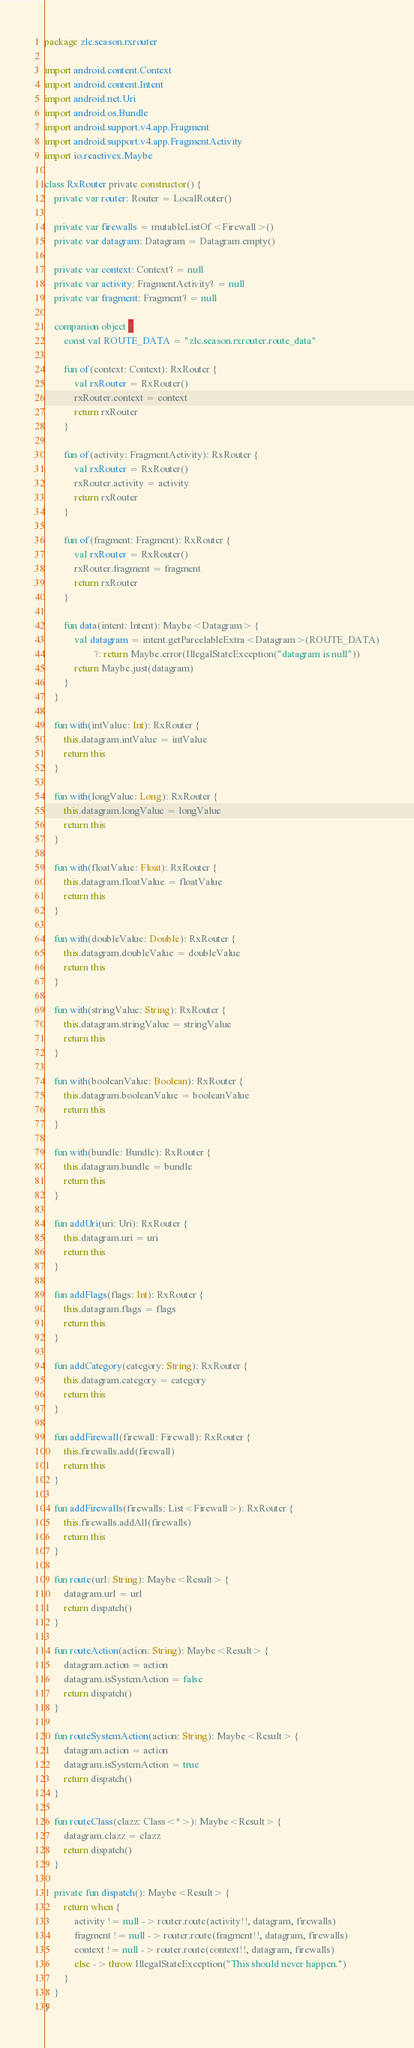<code> <loc_0><loc_0><loc_500><loc_500><_Kotlin_>package zlc.season.rxrouter

import android.content.Context
import android.content.Intent
import android.net.Uri
import android.os.Bundle
import android.support.v4.app.Fragment
import android.support.v4.app.FragmentActivity
import io.reactivex.Maybe

class RxRouter private constructor() {
    private var router: Router = LocalRouter()

    private var firewalls = mutableListOf<Firewall>()
    private var datagram: Datagram = Datagram.empty()

    private var context: Context? = null
    private var activity: FragmentActivity? = null
    private var fragment: Fragment? = null

    companion object {
        const val ROUTE_DATA = "zlc.season.rxrouter.route_data"

        fun of(context: Context): RxRouter {
            val rxRouter = RxRouter()
            rxRouter.context = context
            return rxRouter
        }

        fun of(activity: FragmentActivity): RxRouter {
            val rxRouter = RxRouter()
            rxRouter.activity = activity
            return rxRouter
        }

        fun of(fragment: Fragment): RxRouter {
            val rxRouter = RxRouter()
            rxRouter.fragment = fragment
            return rxRouter
        }

        fun data(intent: Intent): Maybe<Datagram> {
            val datagram = intent.getParcelableExtra<Datagram>(ROUTE_DATA)
                    ?: return Maybe.error(IllegalStateException("datagram is null"))
            return Maybe.just(datagram)
        }
    }

    fun with(intValue: Int): RxRouter {
        this.datagram.intValue = intValue
        return this
    }

    fun with(longValue: Long): RxRouter {
        this.datagram.longValue = longValue
        return this
    }

    fun with(floatValue: Float): RxRouter {
        this.datagram.floatValue = floatValue
        return this
    }

    fun with(doubleValue: Double): RxRouter {
        this.datagram.doubleValue = doubleValue
        return this
    }

    fun with(stringValue: String): RxRouter {
        this.datagram.stringValue = stringValue
        return this
    }

    fun with(booleanValue: Boolean): RxRouter {
        this.datagram.booleanValue = booleanValue
        return this
    }

    fun with(bundle: Bundle): RxRouter {
        this.datagram.bundle = bundle
        return this
    }

    fun addUri(uri: Uri): RxRouter {
        this.datagram.uri = uri
        return this
    }

    fun addFlags(flags: Int): RxRouter {
        this.datagram.flags = flags
        return this
    }

    fun addCategory(category: String): RxRouter {
        this.datagram.category = category
        return this
    }

    fun addFirewall(firewall: Firewall): RxRouter {
        this.firewalls.add(firewall)
        return this
    }

    fun addFirewalls(firewalls: List<Firewall>): RxRouter {
        this.firewalls.addAll(firewalls)
        return this
    }

    fun route(url: String): Maybe<Result> {
        datagram.url = url
        return dispatch()
    }

    fun routeAction(action: String): Maybe<Result> {
        datagram.action = action
        datagram.isSystemAction = false
        return dispatch()
    }

    fun routeSystemAction(action: String): Maybe<Result> {
        datagram.action = action
        datagram.isSystemAction = true
        return dispatch()
    }

    fun routeClass(clazz: Class<*>): Maybe<Result> {
        datagram.clazz = clazz
        return dispatch()
    }

    private fun dispatch(): Maybe<Result> {
        return when {
            activity != null -> router.route(activity!!, datagram, firewalls)
            fragment != null -> router.route(fragment!!, datagram, firewalls)
            context != null -> router.route(context!!, datagram, firewalls)
            else -> throw IllegalStateException("This should never happen.")
        }
    }
}</code> 